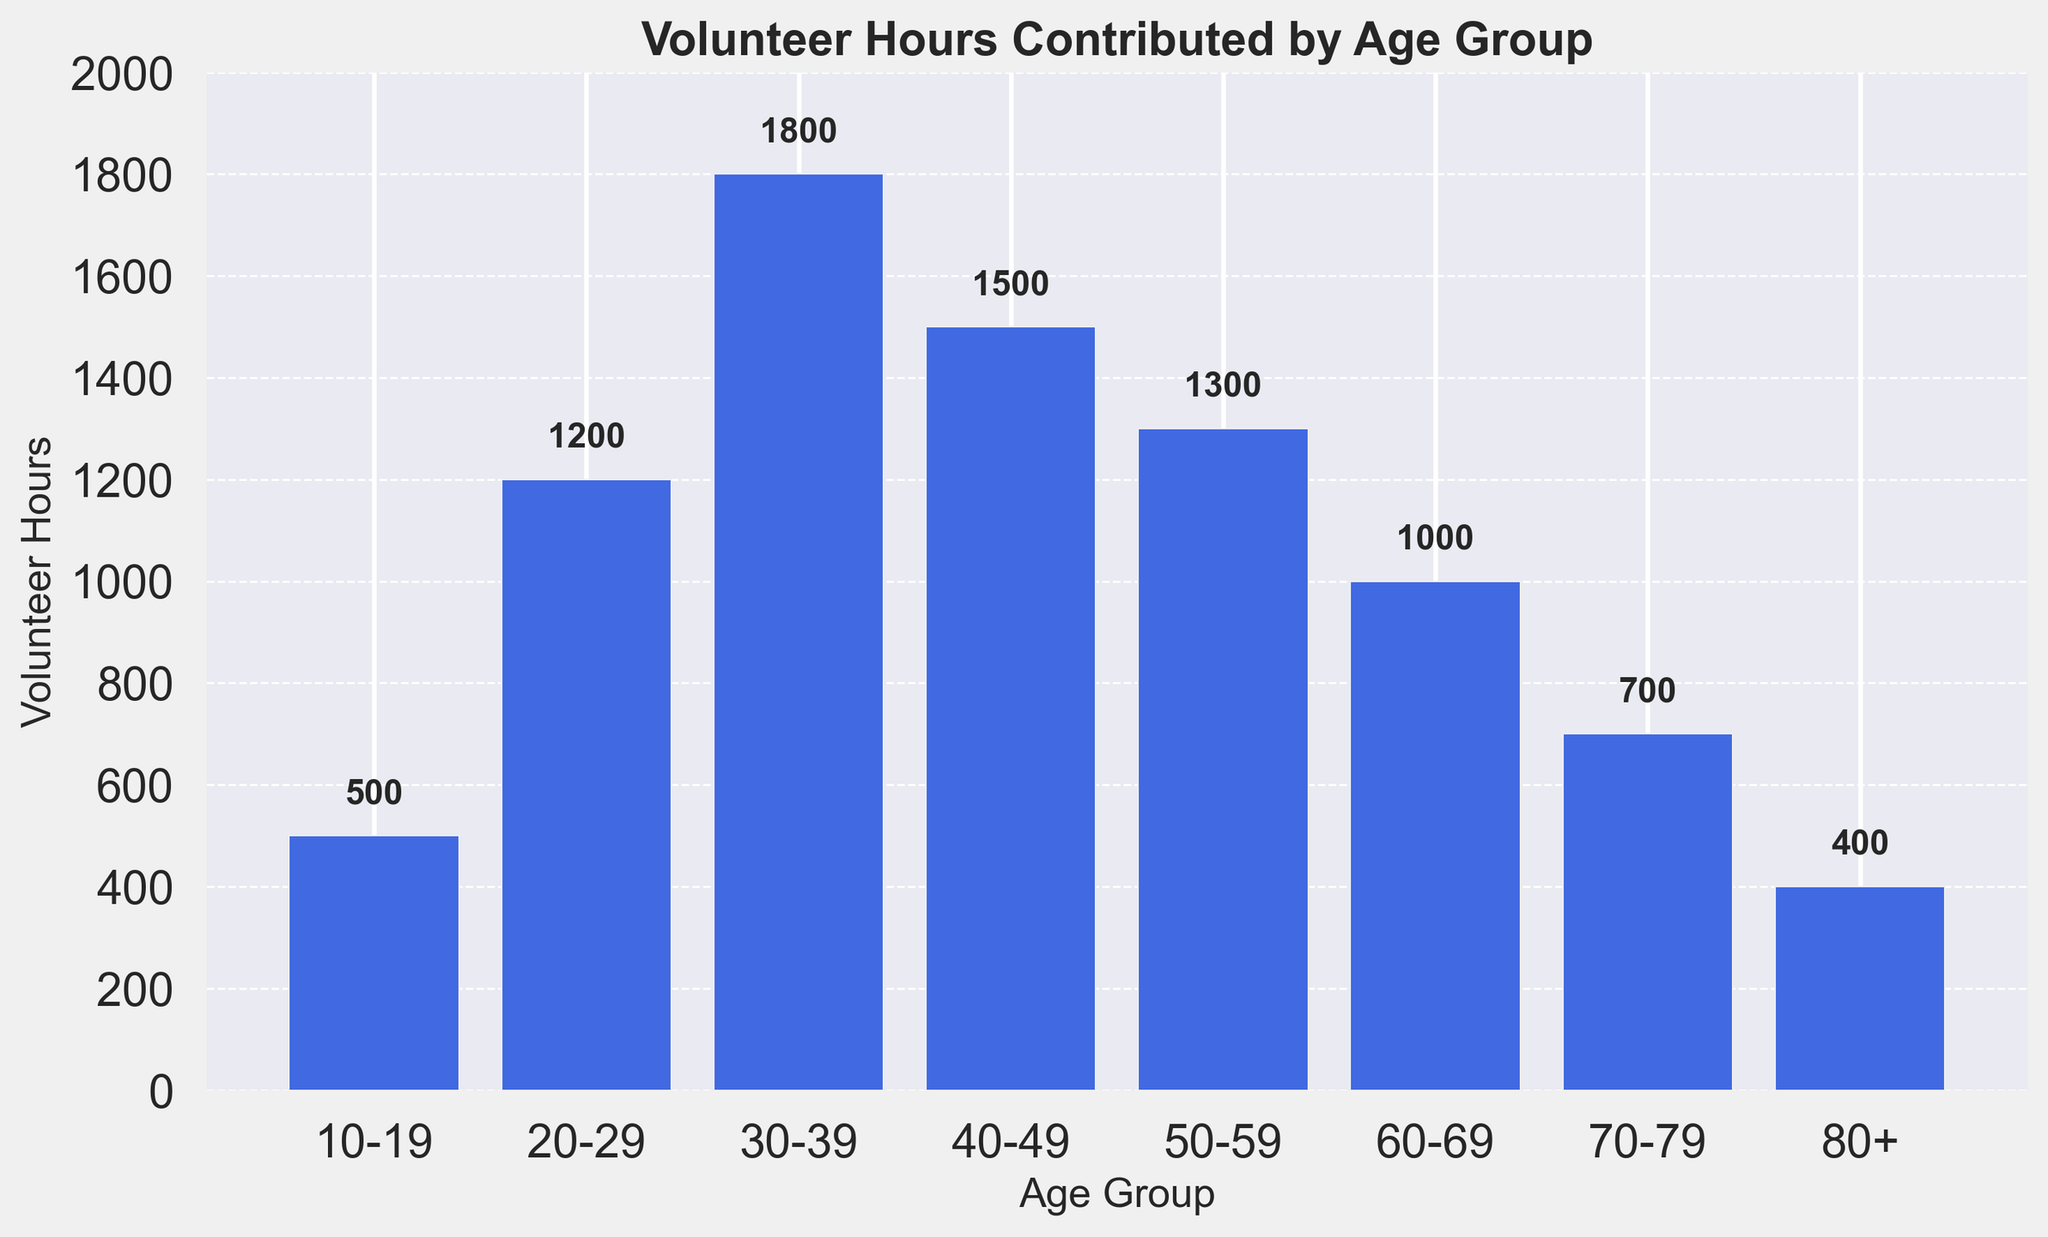What age group contributes the most volunteer hours? To find the age group that contributes the most volunteer hours, we examine the heights of the bars in the chart. The bar representing the age group 30-39 is the tallest, indicating they contribute the most volunteer hours.
Answer: 30-39 Which age group's volunteer hours are less than those contributed by the 40-49 age group? To determine the age groups with fewer volunteer hours than the 40-49 age group, we observe the height of the bars. Age groups 10-19, 60-69, 70-79, and 80+ all have shorter bars compared to the 40-49 group, meaning their volunteer hours are fewer.
Answer: 10-19, 60-69, 70-79, 80+ What is the total number of volunteer hours contributed by age groups 50-59 and 60-69? To calculate the total, we add the volunteer hours for the 50-59 and 60-69 age groups. The 50-59 group contributed 1300 hours, and the 60-69 group contributed 1000 hours. The total is 1300 + 1000 = 2300 hours.
Answer: 2300 By how much do the volunteer hours of the 20-29 age group exceed those of the 10-19 age group? To find the difference, subtract the volunteer hours of the 10-19 group from those of the 20-29 group. The 20-29 group contributed 1200 hours, and the 10-19 group contributed 500 hours. The difference is 1200 - 500 = 700 hours.
Answer: 700 What is the average number of volunteer hours contributed by the age groups from 70-79 and 80+? To get the average, add the volunteer hours of the 70-79 and 80+ age groups and divide by 2. The 70-79 group contributed 700 hours, and the 80+ group contributed 400 hours. The sum is 700 + 400 = 1100, and the average is 1100 / 2 = 550 hours.
Answer: 550 Which age groups contribute equal or more volunteer hours than the 50-59 age group? To identify these age groups, we compare their volunteer hours to those of the 50-59 age group, which contributed 1300 hours. The 20-29, 30-39, and 40-49 age groups all contribute equal or more hours than the 50-59 age group.
Answer: 20-29, 30-39, 40-49 What is the combined total of volunteer hours for the age groups under 40? To find the combined total, sum the volunteer hours of the 10-19, 20-29, and 30-39 age groups. Their contributions are 500, 1200, and 1800 hours, respectively. The total is 500 + 1200 + 1800 = 3500 hours.
Answer: 3500 How many more volunteer hours are contributed by the 30-39 age group compared to the 80+ age group? To determine this, subtract the volunteer hours of the 80+ age group from the 30-39 age group. The 30-39 group contributed 1800 hours, and the 80+ group contributed 400 hours. The difference is 1800 - 400 = 1400 hours.
Answer: 1400 